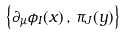<formula> <loc_0><loc_0><loc_500><loc_500>\left \{ \partial _ { \mu } \phi _ { I } ( x ) \, , \, \pi _ { J } ( y ) \right \}</formula> 